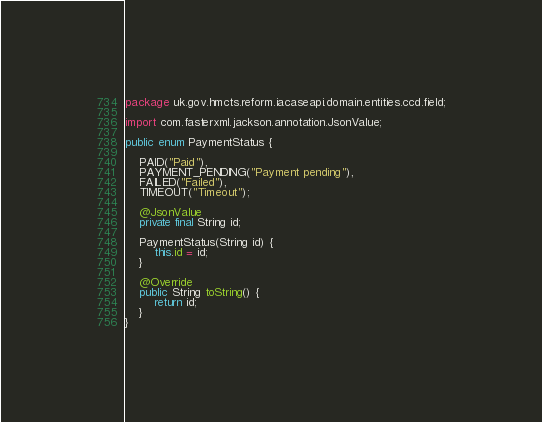<code> <loc_0><loc_0><loc_500><loc_500><_Java_>package uk.gov.hmcts.reform.iacaseapi.domain.entities.ccd.field;

import com.fasterxml.jackson.annotation.JsonValue;

public enum PaymentStatus {

    PAID("Paid"),
    PAYMENT_PENDING("Payment pending"),
    FAILED("Failed"),
    TIMEOUT("Timeout");

    @JsonValue
    private final String id;

    PaymentStatus(String id) {
        this.id = id;
    }

    @Override
    public String toString() {
        return id;
    }
}
</code> 